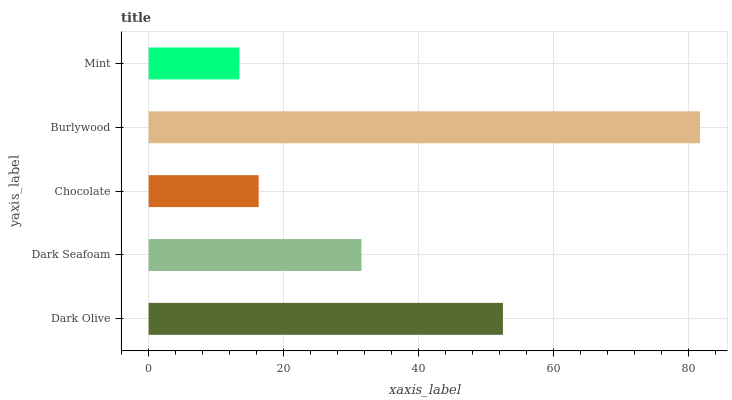Is Mint the minimum?
Answer yes or no. Yes. Is Burlywood the maximum?
Answer yes or no. Yes. Is Dark Seafoam the minimum?
Answer yes or no. No. Is Dark Seafoam the maximum?
Answer yes or no. No. Is Dark Olive greater than Dark Seafoam?
Answer yes or no. Yes. Is Dark Seafoam less than Dark Olive?
Answer yes or no. Yes. Is Dark Seafoam greater than Dark Olive?
Answer yes or no. No. Is Dark Olive less than Dark Seafoam?
Answer yes or no. No. Is Dark Seafoam the high median?
Answer yes or no. Yes. Is Dark Seafoam the low median?
Answer yes or no. Yes. Is Mint the high median?
Answer yes or no. No. Is Dark Olive the low median?
Answer yes or no. No. 